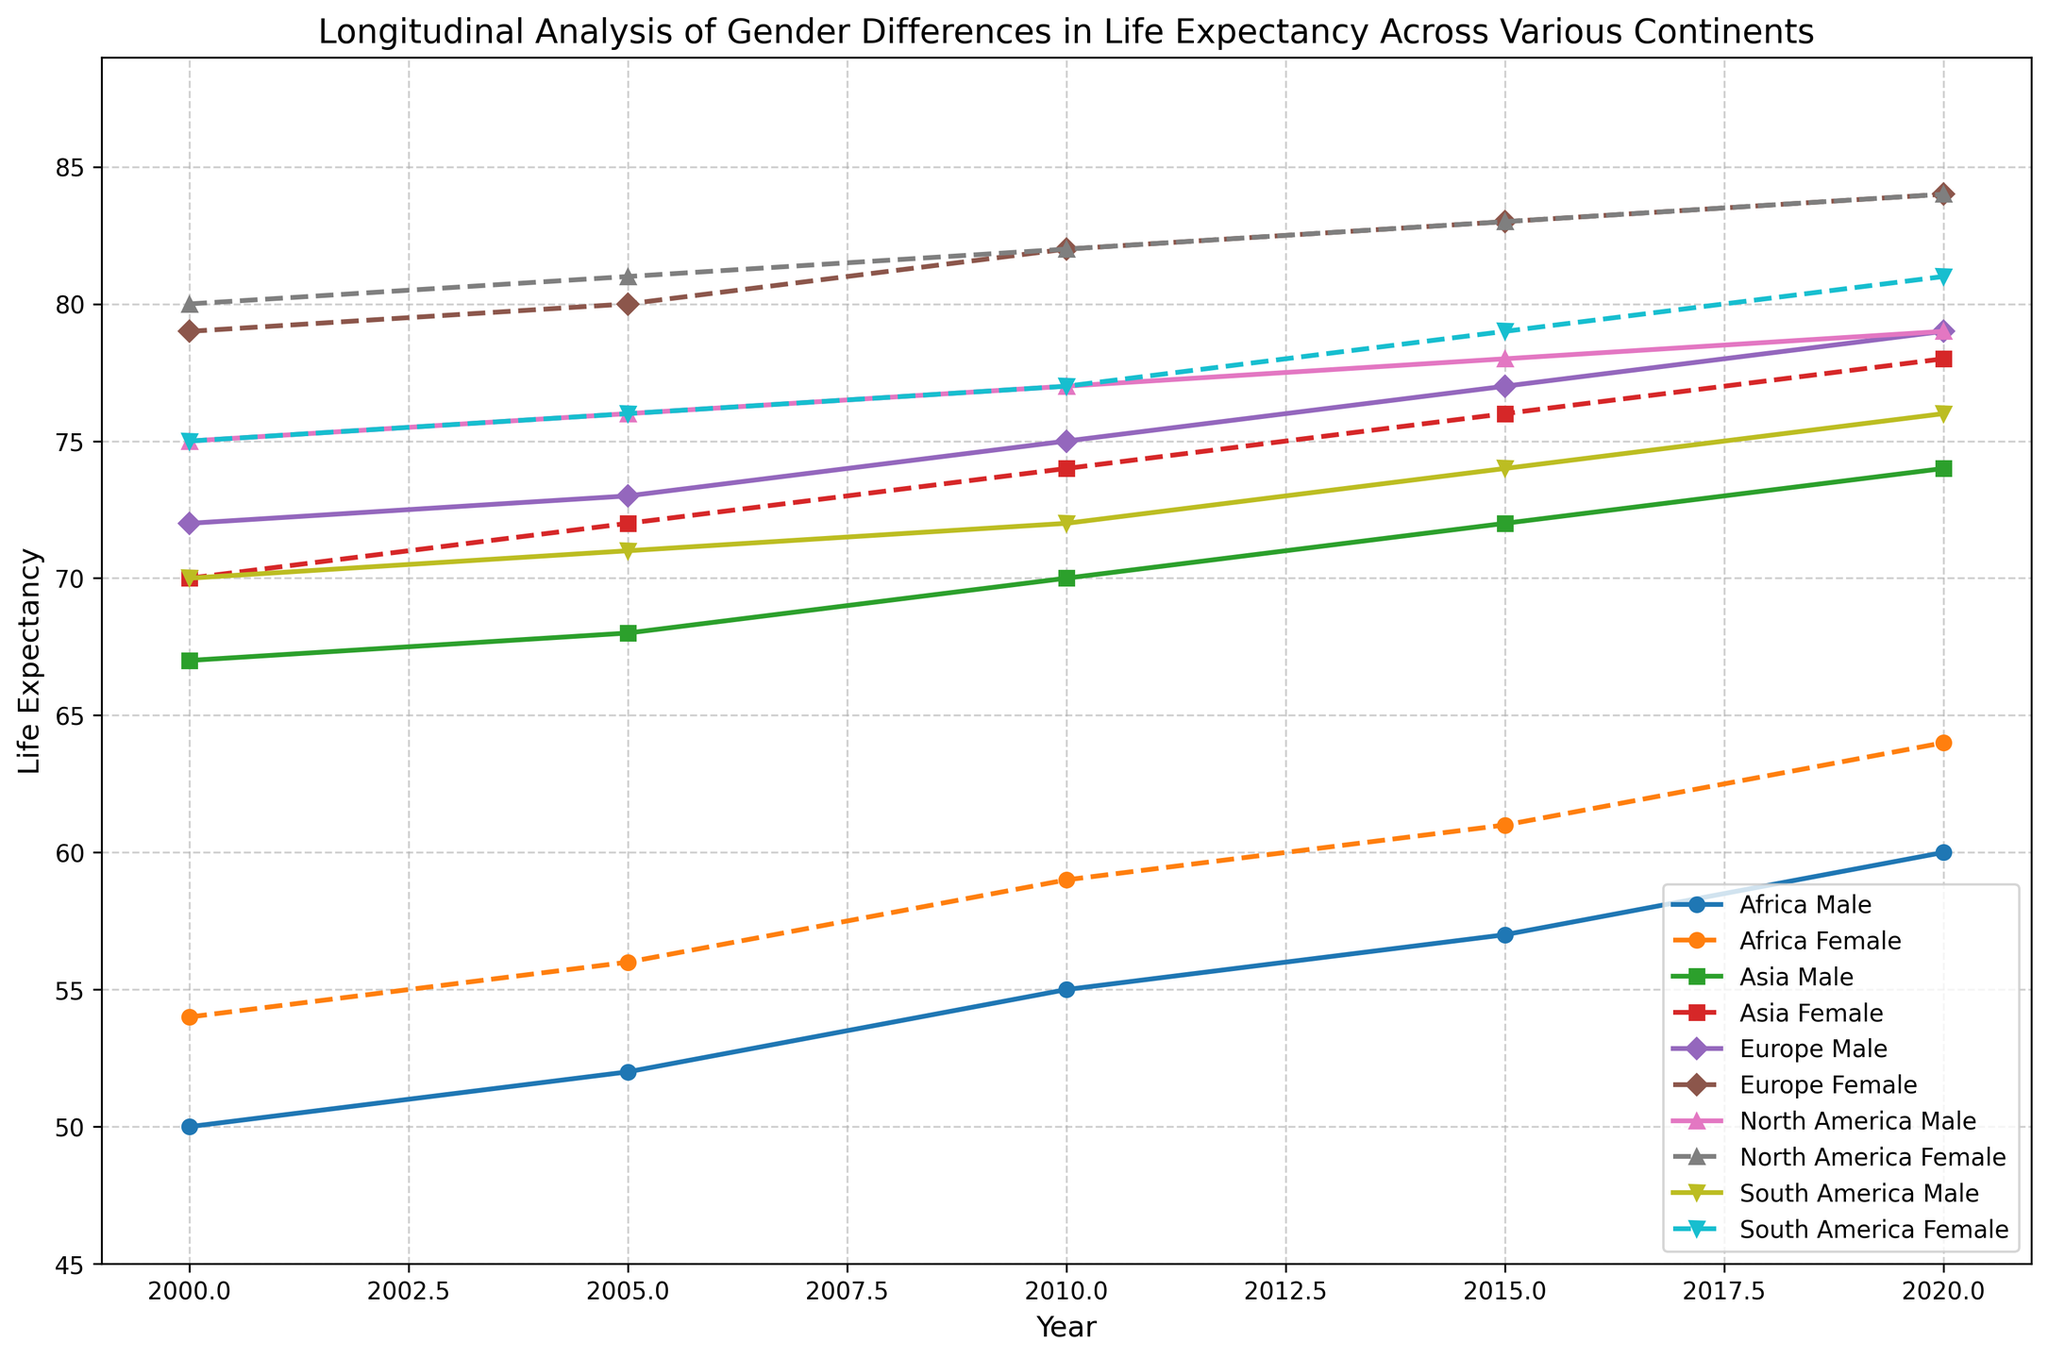What's the difference in life expectancy between males and females in Europe in the year 2000? Find the male and female life expectancy for Europe in 2000 from the figure. Subtract male life expectancy from female life expectancy (79 - 72).
Answer: 7 years Which continent shows the largest increase in female life expectancy from 2000 to 2020? Identify the female life expectancy for each continent in both 2000 and 2020 from the figure. Calculate the increase for each continent and compare them. Africa: 64-54=10, Asia: 78-70=8, Europe: 84-79=5, North America: 84-80=4, South America: 81-75=6. The largest increase is in Africa.
Answer: Africa In which year did North America have the same life expectancy for both genders? Check the figures for North America to find the year where the male and female life expectancy lines intersect or match the same value. This occurs in 2020 with both having a life expectancy of 84 years.
Answer: 2020 Compare the trend of male life expectancy in Africa to that in Asia from 2000 to 2020. Observe both the male life expectancy lines for Africa and Asia on the figure. Africa's trend shows a gradual increase from 50 to 60, while Asia's trend is slightly steeper, increasing from 67 to 74.
Answer: Both increasing, Asia steeper What's the average female life expectancy in Europe from 2000 to 2020? Extract the female life expectancy for Europe for each year (2000: 79, 2005: 80, 2010: 82, 2015: 83, 2020: 84). Calculate the average: (79 + 80 + 82 + 83 + 84) / 5.
Answer: 81.6 years Which continent had the highest male life expectancy in 2010? Check the figure for 2010 and compare the male life expectancy values across continents: Africa: 55, Asia: 70, Europe: 75, North America: 77, South America: 72. North America has the highest value.
Answer: North America Which gender generally has a higher life expectancy in each continent across all years? Observe the lines for each gender and continent across all years in the figure. The female life expectancy line is consistently higher than the male life expectancy line for all continents and years.
Answer: Female By how many years did female life expectancy in South America increase from 2000 to 2015? Identify female life expectancy in South America for 2000 (75) and 2015 (79). Subtract the 2000 value from the 2015 value (79 - 75).
Answer: 4 years What is the smallest gap between male and female life expectancy in any continent and year combination? Calculate the difference between male and female life expectancy for each year and continent, and identify the smallest gap. For example, if Europe has values (2020:m 79, f 84), the gap is 5. By systematically checking all combinations, Asia in 2015 has the smallest gap of 4 years (m 72, f 76).
Answer: 4 years 